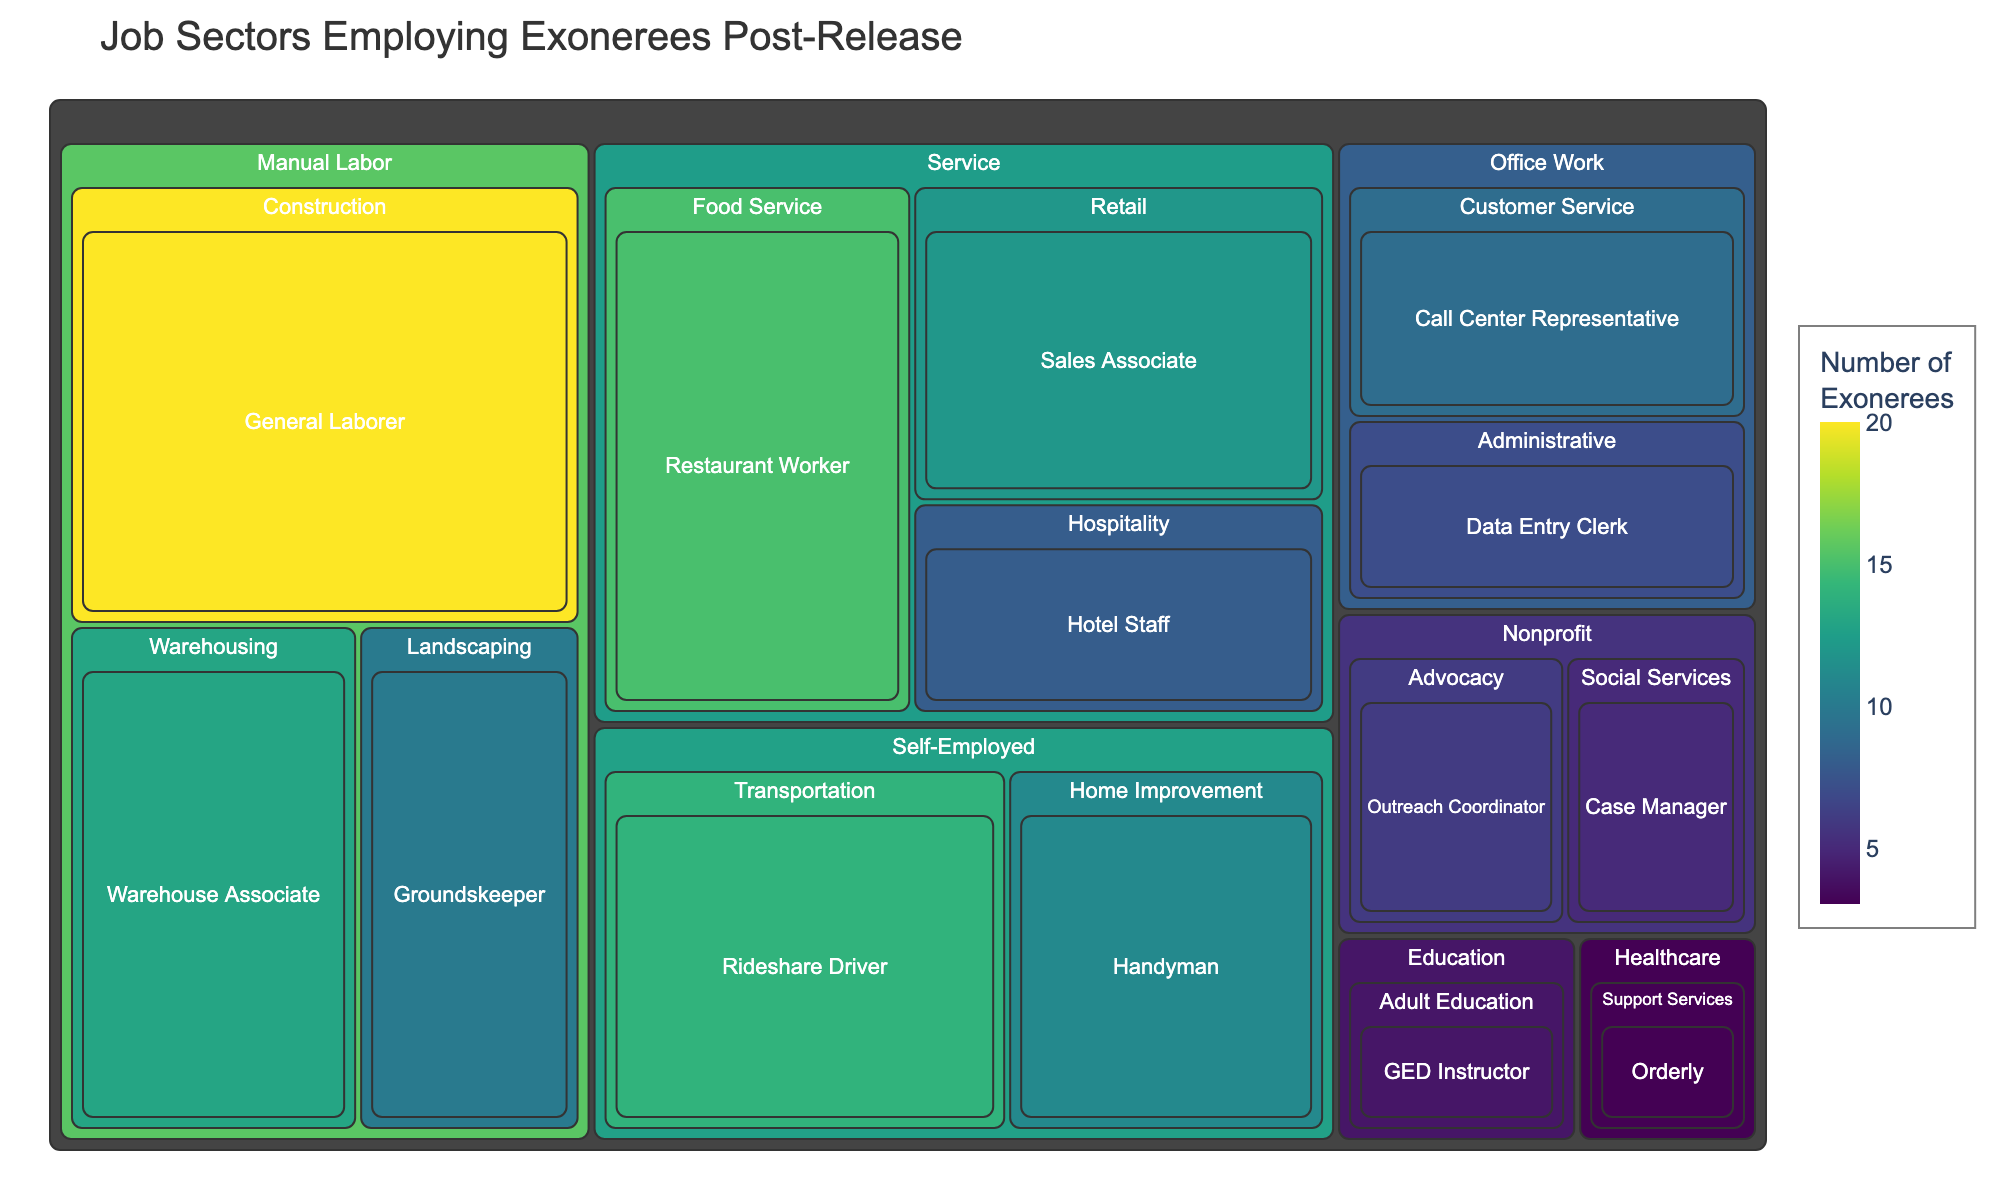What is the title of the treemap? The title of the treemap can usually be found at the top of the figure, and it often describes what the treemap is showing. In this case, it is describing job sectors employing exonerees post-release.
Answer: Job Sectors Employing Exonerees Post-Release Which job sector employs the most exonerees? The job sector that employs the most exonerees will be the one with the largest area in the treemap. By comparing the areas of each Job Sector, we can identify which one is the largest.
Answer: Manual Labor How many total exonerees are employed in the Service sector? We need to add the values for all the roles within the Service sector. These include Restaurant Worker (15), Sales Associate (12), and Hotel Staff (8). Summing these values gives us the total.
Answer: 35 Which role within the Manual Labor sector employs the most exonerees? Within the Manual Labor sector, compare the areas corresponding to General Laborer, Groundskeeper, and Warehouse Associate. The role with the largest area is the one that employs the most exonerees.
Answer: General Laborer How does the number of exonerees employed as Case Managers in the Nonprofit sector compare to those employed as Data Entry Clerks in the Office Work sector? Locate and compare the areas for 'Case Manager' within 'Nonprofit' and 'Data Entry Clerk' within 'Office Work'. The area representing the larger value directly indicates which employs more.
Answer: Data Entry Clerk employs more than Case Manager What is the sum of exonerees employed in Office Work and Nonprofit sectors combined? Add the total number of exonerees for each role within these two sectors: Office Work (Data Entry Clerk: 7, Call Center Representative: 9) and Nonprofit (Outreach Coordinator: 6, Case Manager: 5). The sum is 7 + 9 + 6 + 5.
Answer: 27 Which sector has the smallest representation in the treemap? The sector with the smallest total value will have the smallest area on the treemap. Compare the total area sizes of each sector to identify the smallest.
Answer: Healthcare What is the visual pattern of color distribution, and what does it indicate? The color distribution in a treemap often reflects the value represented, with darker or more intense colors indicating higher values. Look at the color scale and compare hues across the figure. Darker colors are placed at jobs with higher exoneree counts.
Answer: Darker colors are typically found in sectors with higher exoneree counts How many more exonerees work as Rideshare Drivers compared to Groundskeepers? Find and compare the values for Rideshare Driver (14) and Groundskeeper (10). Then, subtract the smaller value from the larger one to get the difference.
Answer: 4 more exonerees What is the average number of exonerees employed per role in the Service sector? Calculate the total number of exonerees employed in the Service sector (35) and divide by the number of roles within that sector (3). The calculation is 35 / 3.
Answer: Approximately 11.67 